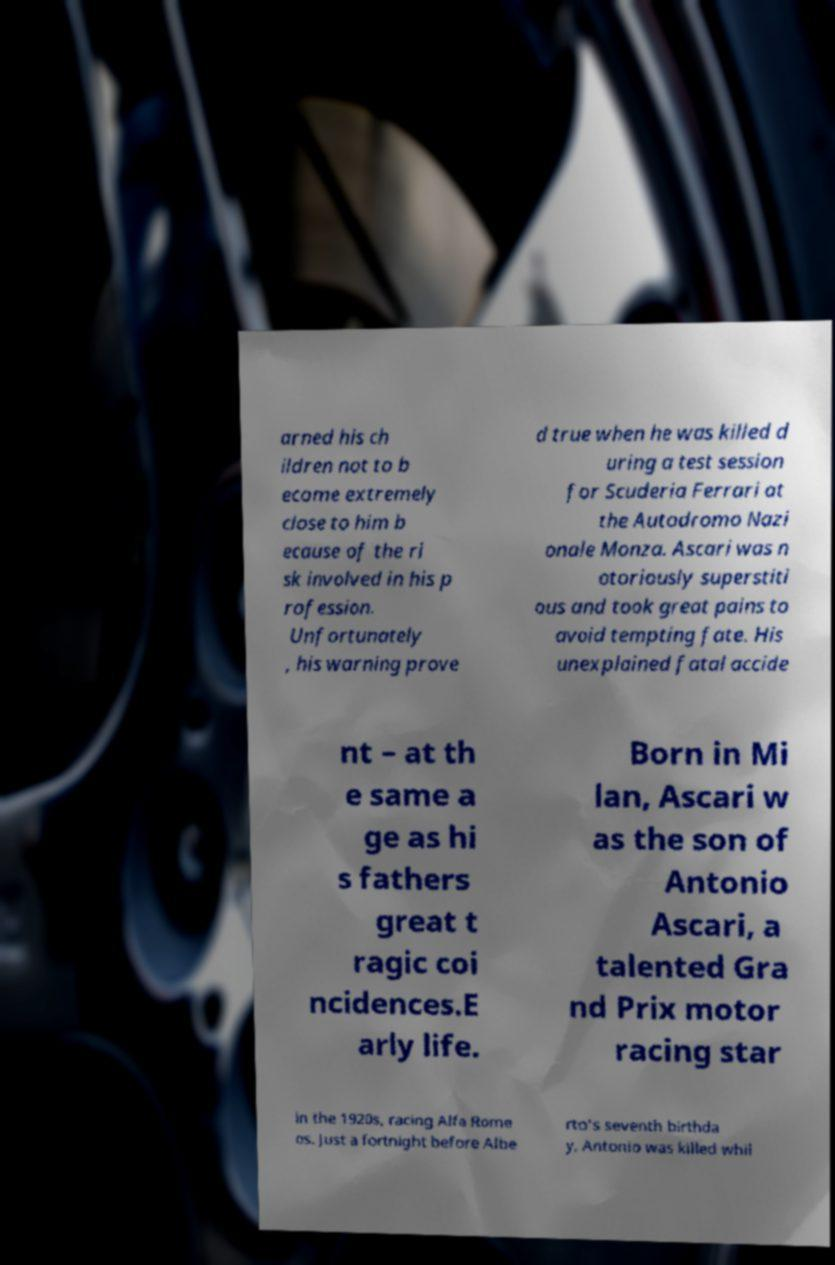Can you read and provide the text displayed in the image?This photo seems to have some interesting text. Can you extract and type it out for me? arned his ch ildren not to b ecome extremely close to him b ecause of the ri sk involved in his p rofession. Unfortunately , his warning prove d true when he was killed d uring a test session for Scuderia Ferrari at the Autodromo Nazi onale Monza. Ascari was n otoriously superstiti ous and took great pains to avoid tempting fate. His unexplained fatal accide nt – at th e same a ge as hi s fathers great t ragic coi ncidences.E arly life. Born in Mi lan, Ascari w as the son of Antonio Ascari, a talented Gra nd Prix motor racing star in the 1920s, racing Alfa Rome os. Just a fortnight before Albe rto's seventh birthda y, Antonio was killed whil 